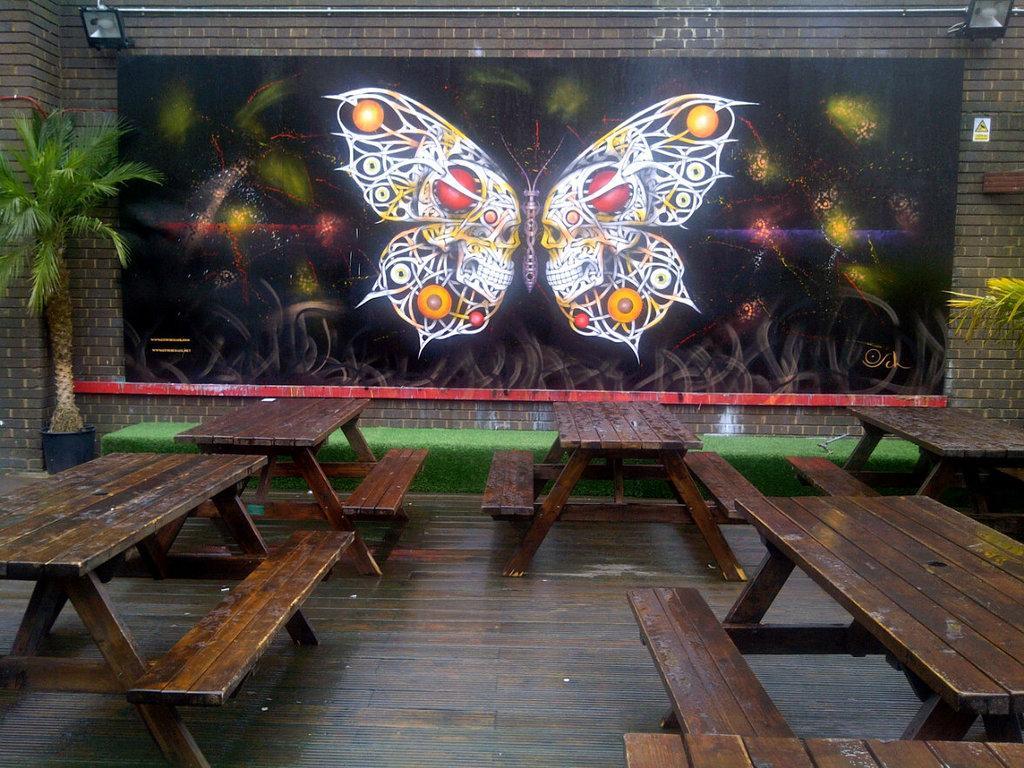Could you give a brief overview of what you see in this image? In this image there are benches, in front of the benches on the wall there is a butterfly poster, above the poster there are two focus lights and there are two trees. 